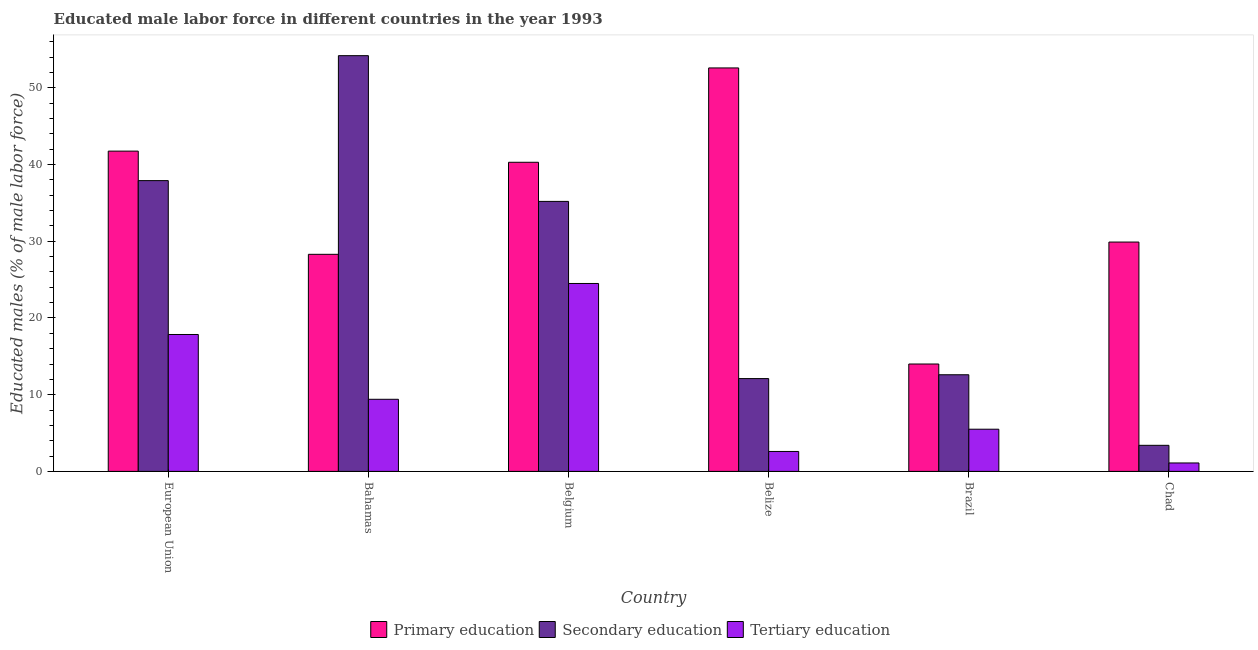Are the number of bars per tick equal to the number of legend labels?
Offer a very short reply. Yes. Are the number of bars on each tick of the X-axis equal?
Keep it short and to the point. Yes. What is the label of the 6th group of bars from the left?
Make the answer very short. Chad. In how many cases, is the number of bars for a given country not equal to the number of legend labels?
Offer a terse response. 0. What is the percentage of male labor force who received secondary education in Belgium?
Provide a succinct answer. 35.2. Across all countries, what is the maximum percentage of male labor force who received secondary education?
Make the answer very short. 54.2. In which country was the percentage of male labor force who received secondary education maximum?
Your answer should be very brief. Bahamas. In which country was the percentage of male labor force who received secondary education minimum?
Offer a very short reply. Chad. What is the total percentage of male labor force who received secondary education in the graph?
Make the answer very short. 155.41. What is the difference between the percentage of male labor force who received primary education in Chad and that in European Union?
Your answer should be compact. -11.86. What is the difference between the percentage of male labor force who received tertiary education in Bahamas and the percentage of male labor force who received primary education in European Union?
Your answer should be very brief. -32.36. What is the average percentage of male labor force who received primary education per country?
Give a very brief answer. 34.48. What is the difference between the percentage of male labor force who received primary education and percentage of male labor force who received tertiary education in European Union?
Offer a terse response. 23.91. In how many countries, is the percentage of male labor force who received tertiary education greater than 24 %?
Offer a terse response. 1. What is the ratio of the percentage of male labor force who received primary education in Belgium to that in European Union?
Offer a terse response. 0.97. Is the percentage of male labor force who received primary education in Bahamas less than that in Belgium?
Ensure brevity in your answer.  Yes. Is the difference between the percentage of male labor force who received tertiary education in Chad and European Union greater than the difference between the percentage of male labor force who received secondary education in Chad and European Union?
Make the answer very short. Yes. What is the difference between the highest and the second highest percentage of male labor force who received tertiary education?
Your answer should be compact. 6.65. What is the difference between the highest and the lowest percentage of male labor force who received secondary education?
Offer a terse response. 50.8. In how many countries, is the percentage of male labor force who received primary education greater than the average percentage of male labor force who received primary education taken over all countries?
Make the answer very short. 3. What does the 3rd bar from the right in European Union represents?
Give a very brief answer. Primary education. Is it the case that in every country, the sum of the percentage of male labor force who received primary education and percentage of male labor force who received secondary education is greater than the percentage of male labor force who received tertiary education?
Offer a very short reply. Yes. How many bars are there?
Ensure brevity in your answer.  18. Are the values on the major ticks of Y-axis written in scientific E-notation?
Ensure brevity in your answer.  No. How are the legend labels stacked?
Make the answer very short. Horizontal. What is the title of the graph?
Make the answer very short. Educated male labor force in different countries in the year 1993. Does "Maunufacturing" appear as one of the legend labels in the graph?
Keep it short and to the point. No. What is the label or title of the X-axis?
Offer a terse response. Country. What is the label or title of the Y-axis?
Offer a terse response. Educated males (% of male labor force). What is the Educated males (% of male labor force) in Primary education in European Union?
Your answer should be very brief. 41.76. What is the Educated males (% of male labor force) in Secondary education in European Union?
Make the answer very short. 37.91. What is the Educated males (% of male labor force) in Tertiary education in European Union?
Provide a succinct answer. 17.85. What is the Educated males (% of male labor force) of Primary education in Bahamas?
Your answer should be compact. 28.3. What is the Educated males (% of male labor force) of Secondary education in Bahamas?
Offer a very short reply. 54.2. What is the Educated males (% of male labor force) in Tertiary education in Bahamas?
Your answer should be very brief. 9.4. What is the Educated males (% of male labor force) of Primary education in Belgium?
Ensure brevity in your answer.  40.3. What is the Educated males (% of male labor force) of Secondary education in Belgium?
Ensure brevity in your answer.  35.2. What is the Educated males (% of male labor force) in Primary education in Belize?
Make the answer very short. 52.6. What is the Educated males (% of male labor force) in Secondary education in Belize?
Keep it short and to the point. 12.1. What is the Educated males (% of male labor force) of Tertiary education in Belize?
Provide a succinct answer. 2.6. What is the Educated males (% of male labor force) of Secondary education in Brazil?
Give a very brief answer. 12.6. What is the Educated males (% of male labor force) in Tertiary education in Brazil?
Provide a short and direct response. 5.5. What is the Educated males (% of male labor force) of Primary education in Chad?
Offer a terse response. 29.9. What is the Educated males (% of male labor force) in Secondary education in Chad?
Give a very brief answer. 3.4. What is the Educated males (% of male labor force) of Tertiary education in Chad?
Ensure brevity in your answer.  1.1. Across all countries, what is the maximum Educated males (% of male labor force) in Primary education?
Provide a succinct answer. 52.6. Across all countries, what is the maximum Educated males (% of male labor force) of Secondary education?
Make the answer very short. 54.2. Across all countries, what is the maximum Educated males (% of male labor force) of Tertiary education?
Your response must be concise. 24.5. Across all countries, what is the minimum Educated males (% of male labor force) of Primary education?
Your answer should be compact. 14. Across all countries, what is the minimum Educated males (% of male labor force) of Secondary education?
Provide a short and direct response. 3.4. Across all countries, what is the minimum Educated males (% of male labor force) of Tertiary education?
Keep it short and to the point. 1.1. What is the total Educated males (% of male labor force) in Primary education in the graph?
Provide a short and direct response. 206.86. What is the total Educated males (% of male labor force) in Secondary education in the graph?
Provide a succinct answer. 155.41. What is the total Educated males (% of male labor force) in Tertiary education in the graph?
Provide a short and direct response. 60.95. What is the difference between the Educated males (% of male labor force) in Primary education in European Union and that in Bahamas?
Your response must be concise. 13.46. What is the difference between the Educated males (% of male labor force) of Secondary education in European Union and that in Bahamas?
Your answer should be compact. -16.29. What is the difference between the Educated males (% of male labor force) of Tertiary education in European Union and that in Bahamas?
Your answer should be very brief. 8.45. What is the difference between the Educated males (% of male labor force) of Primary education in European Union and that in Belgium?
Offer a very short reply. 1.46. What is the difference between the Educated males (% of male labor force) in Secondary education in European Union and that in Belgium?
Provide a short and direct response. 2.71. What is the difference between the Educated males (% of male labor force) of Tertiary education in European Union and that in Belgium?
Give a very brief answer. -6.65. What is the difference between the Educated males (% of male labor force) in Primary education in European Union and that in Belize?
Your answer should be very brief. -10.84. What is the difference between the Educated males (% of male labor force) in Secondary education in European Union and that in Belize?
Make the answer very short. 25.81. What is the difference between the Educated males (% of male labor force) of Tertiary education in European Union and that in Belize?
Your answer should be compact. 15.25. What is the difference between the Educated males (% of male labor force) in Primary education in European Union and that in Brazil?
Your answer should be compact. 27.76. What is the difference between the Educated males (% of male labor force) of Secondary education in European Union and that in Brazil?
Your answer should be compact. 25.31. What is the difference between the Educated males (% of male labor force) in Tertiary education in European Union and that in Brazil?
Make the answer very short. 12.35. What is the difference between the Educated males (% of male labor force) of Primary education in European Union and that in Chad?
Offer a terse response. 11.86. What is the difference between the Educated males (% of male labor force) in Secondary education in European Union and that in Chad?
Make the answer very short. 34.51. What is the difference between the Educated males (% of male labor force) of Tertiary education in European Union and that in Chad?
Your answer should be very brief. 16.75. What is the difference between the Educated males (% of male labor force) of Tertiary education in Bahamas and that in Belgium?
Provide a succinct answer. -15.1. What is the difference between the Educated males (% of male labor force) in Primary education in Bahamas and that in Belize?
Your answer should be very brief. -24.3. What is the difference between the Educated males (% of male labor force) in Secondary education in Bahamas and that in Belize?
Make the answer very short. 42.1. What is the difference between the Educated males (% of male labor force) of Secondary education in Bahamas and that in Brazil?
Your answer should be very brief. 41.6. What is the difference between the Educated males (% of male labor force) of Primary education in Bahamas and that in Chad?
Give a very brief answer. -1.6. What is the difference between the Educated males (% of male labor force) of Secondary education in Bahamas and that in Chad?
Provide a short and direct response. 50.8. What is the difference between the Educated males (% of male labor force) in Secondary education in Belgium and that in Belize?
Ensure brevity in your answer.  23.1. What is the difference between the Educated males (% of male labor force) of Tertiary education in Belgium and that in Belize?
Your answer should be compact. 21.9. What is the difference between the Educated males (% of male labor force) of Primary education in Belgium and that in Brazil?
Your response must be concise. 26.3. What is the difference between the Educated males (% of male labor force) of Secondary education in Belgium and that in Brazil?
Offer a very short reply. 22.6. What is the difference between the Educated males (% of male labor force) in Primary education in Belgium and that in Chad?
Offer a terse response. 10.4. What is the difference between the Educated males (% of male labor force) of Secondary education in Belgium and that in Chad?
Provide a short and direct response. 31.8. What is the difference between the Educated males (% of male labor force) of Tertiary education in Belgium and that in Chad?
Provide a short and direct response. 23.4. What is the difference between the Educated males (% of male labor force) of Primary education in Belize and that in Brazil?
Give a very brief answer. 38.6. What is the difference between the Educated males (% of male labor force) in Primary education in Belize and that in Chad?
Ensure brevity in your answer.  22.7. What is the difference between the Educated males (% of male labor force) of Primary education in Brazil and that in Chad?
Provide a succinct answer. -15.9. What is the difference between the Educated males (% of male labor force) of Secondary education in Brazil and that in Chad?
Ensure brevity in your answer.  9.2. What is the difference between the Educated males (% of male labor force) of Tertiary education in Brazil and that in Chad?
Offer a very short reply. 4.4. What is the difference between the Educated males (% of male labor force) of Primary education in European Union and the Educated males (% of male labor force) of Secondary education in Bahamas?
Keep it short and to the point. -12.44. What is the difference between the Educated males (% of male labor force) in Primary education in European Union and the Educated males (% of male labor force) in Tertiary education in Bahamas?
Your answer should be compact. 32.36. What is the difference between the Educated males (% of male labor force) of Secondary education in European Union and the Educated males (% of male labor force) of Tertiary education in Bahamas?
Offer a very short reply. 28.51. What is the difference between the Educated males (% of male labor force) of Primary education in European Union and the Educated males (% of male labor force) of Secondary education in Belgium?
Your answer should be compact. 6.56. What is the difference between the Educated males (% of male labor force) in Primary education in European Union and the Educated males (% of male labor force) in Tertiary education in Belgium?
Your response must be concise. 17.26. What is the difference between the Educated males (% of male labor force) in Secondary education in European Union and the Educated males (% of male labor force) in Tertiary education in Belgium?
Provide a short and direct response. 13.41. What is the difference between the Educated males (% of male labor force) of Primary education in European Union and the Educated males (% of male labor force) of Secondary education in Belize?
Give a very brief answer. 29.66. What is the difference between the Educated males (% of male labor force) in Primary education in European Union and the Educated males (% of male labor force) in Tertiary education in Belize?
Make the answer very short. 39.16. What is the difference between the Educated males (% of male labor force) of Secondary education in European Union and the Educated males (% of male labor force) of Tertiary education in Belize?
Your answer should be very brief. 35.31. What is the difference between the Educated males (% of male labor force) of Primary education in European Union and the Educated males (% of male labor force) of Secondary education in Brazil?
Make the answer very short. 29.16. What is the difference between the Educated males (% of male labor force) of Primary education in European Union and the Educated males (% of male labor force) of Tertiary education in Brazil?
Your answer should be compact. 36.26. What is the difference between the Educated males (% of male labor force) of Secondary education in European Union and the Educated males (% of male labor force) of Tertiary education in Brazil?
Provide a short and direct response. 32.41. What is the difference between the Educated males (% of male labor force) in Primary education in European Union and the Educated males (% of male labor force) in Secondary education in Chad?
Provide a short and direct response. 38.36. What is the difference between the Educated males (% of male labor force) of Primary education in European Union and the Educated males (% of male labor force) of Tertiary education in Chad?
Ensure brevity in your answer.  40.66. What is the difference between the Educated males (% of male labor force) in Secondary education in European Union and the Educated males (% of male labor force) in Tertiary education in Chad?
Make the answer very short. 36.81. What is the difference between the Educated males (% of male labor force) of Primary education in Bahamas and the Educated males (% of male labor force) of Secondary education in Belgium?
Provide a short and direct response. -6.9. What is the difference between the Educated males (% of male labor force) of Secondary education in Bahamas and the Educated males (% of male labor force) of Tertiary education in Belgium?
Offer a terse response. 29.7. What is the difference between the Educated males (% of male labor force) of Primary education in Bahamas and the Educated males (% of male labor force) of Tertiary education in Belize?
Ensure brevity in your answer.  25.7. What is the difference between the Educated males (% of male labor force) in Secondary education in Bahamas and the Educated males (% of male labor force) in Tertiary education in Belize?
Provide a short and direct response. 51.6. What is the difference between the Educated males (% of male labor force) in Primary education in Bahamas and the Educated males (% of male labor force) in Secondary education in Brazil?
Keep it short and to the point. 15.7. What is the difference between the Educated males (% of male labor force) of Primary education in Bahamas and the Educated males (% of male labor force) of Tertiary education in Brazil?
Provide a short and direct response. 22.8. What is the difference between the Educated males (% of male labor force) of Secondary education in Bahamas and the Educated males (% of male labor force) of Tertiary education in Brazil?
Provide a succinct answer. 48.7. What is the difference between the Educated males (% of male labor force) in Primary education in Bahamas and the Educated males (% of male labor force) in Secondary education in Chad?
Make the answer very short. 24.9. What is the difference between the Educated males (% of male labor force) of Primary education in Bahamas and the Educated males (% of male labor force) of Tertiary education in Chad?
Provide a short and direct response. 27.2. What is the difference between the Educated males (% of male labor force) in Secondary education in Bahamas and the Educated males (% of male labor force) in Tertiary education in Chad?
Your answer should be compact. 53.1. What is the difference between the Educated males (% of male labor force) of Primary education in Belgium and the Educated males (% of male labor force) of Secondary education in Belize?
Your answer should be compact. 28.2. What is the difference between the Educated males (% of male labor force) of Primary education in Belgium and the Educated males (% of male labor force) of Tertiary education in Belize?
Offer a very short reply. 37.7. What is the difference between the Educated males (% of male labor force) of Secondary education in Belgium and the Educated males (% of male labor force) of Tertiary education in Belize?
Provide a short and direct response. 32.6. What is the difference between the Educated males (% of male labor force) of Primary education in Belgium and the Educated males (% of male labor force) of Secondary education in Brazil?
Provide a short and direct response. 27.7. What is the difference between the Educated males (% of male labor force) in Primary education in Belgium and the Educated males (% of male labor force) in Tertiary education in Brazil?
Offer a very short reply. 34.8. What is the difference between the Educated males (% of male labor force) in Secondary education in Belgium and the Educated males (% of male labor force) in Tertiary education in Brazil?
Your answer should be very brief. 29.7. What is the difference between the Educated males (% of male labor force) in Primary education in Belgium and the Educated males (% of male labor force) in Secondary education in Chad?
Make the answer very short. 36.9. What is the difference between the Educated males (% of male labor force) of Primary education in Belgium and the Educated males (% of male labor force) of Tertiary education in Chad?
Your answer should be compact. 39.2. What is the difference between the Educated males (% of male labor force) of Secondary education in Belgium and the Educated males (% of male labor force) of Tertiary education in Chad?
Keep it short and to the point. 34.1. What is the difference between the Educated males (% of male labor force) of Primary education in Belize and the Educated males (% of male labor force) of Secondary education in Brazil?
Provide a short and direct response. 40. What is the difference between the Educated males (% of male labor force) in Primary education in Belize and the Educated males (% of male labor force) in Tertiary education in Brazil?
Give a very brief answer. 47.1. What is the difference between the Educated males (% of male labor force) in Primary education in Belize and the Educated males (% of male labor force) in Secondary education in Chad?
Offer a very short reply. 49.2. What is the difference between the Educated males (% of male labor force) of Primary education in Belize and the Educated males (% of male labor force) of Tertiary education in Chad?
Your answer should be compact. 51.5. What is the difference between the Educated males (% of male labor force) in Primary education in Brazil and the Educated males (% of male labor force) in Secondary education in Chad?
Your response must be concise. 10.6. What is the difference between the Educated males (% of male labor force) of Primary education in Brazil and the Educated males (% of male labor force) of Tertiary education in Chad?
Your response must be concise. 12.9. What is the difference between the Educated males (% of male labor force) of Secondary education in Brazil and the Educated males (% of male labor force) of Tertiary education in Chad?
Your answer should be compact. 11.5. What is the average Educated males (% of male labor force) in Primary education per country?
Offer a terse response. 34.48. What is the average Educated males (% of male labor force) of Secondary education per country?
Provide a succinct answer. 25.9. What is the average Educated males (% of male labor force) of Tertiary education per country?
Make the answer very short. 10.16. What is the difference between the Educated males (% of male labor force) in Primary education and Educated males (% of male labor force) in Secondary education in European Union?
Make the answer very short. 3.85. What is the difference between the Educated males (% of male labor force) in Primary education and Educated males (% of male labor force) in Tertiary education in European Union?
Your answer should be very brief. 23.91. What is the difference between the Educated males (% of male labor force) in Secondary education and Educated males (% of male labor force) in Tertiary education in European Union?
Your response must be concise. 20.06. What is the difference between the Educated males (% of male labor force) in Primary education and Educated males (% of male labor force) in Secondary education in Bahamas?
Keep it short and to the point. -25.9. What is the difference between the Educated males (% of male labor force) of Primary education and Educated males (% of male labor force) of Tertiary education in Bahamas?
Ensure brevity in your answer.  18.9. What is the difference between the Educated males (% of male labor force) in Secondary education and Educated males (% of male labor force) in Tertiary education in Bahamas?
Offer a terse response. 44.8. What is the difference between the Educated males (% of male labor force) of Secondary education and Educated males (% of male labor force) of Tertiary education in Belgium?
Offer a very short reply. 10.7. What is the difference between the Educated males (% of male labor force) in Primary education and Educated males (% of male labor force) in Secondary education in Belize?
Offer a very short reply. 40.5. What is the difference between the Educated males (% of male labor force) in Secondary education and Educated males (% of male labor force) in Tertiary education in Belize?
Keep it short and to the point. 9.5. What is the difference between the Educated males (% of male labor force) of Primary education and Educated males (% of male labor force) of Secondary education in Brazil?
Your response must be concise. 1.4. What is the difference between the Educated males (% of male labor force) of Primary education and Educated males (% of male labor force) of Tertiary education in Brazil?
Your answer should be very brief. 8.5. What is the difference between the Educated males (% of male labor force) in Primary education and Educated males (% of male labor force) in Tertiary education in Chad?
Offer a terse response. 28.8. What is the difference between the Educated males (% of male labor force) of Secondary education and Educated males (% of male labor force) of Tertiary education in Chad?
Your answer should be very brief. 2.3. What is the ratio of the Educated males (% of male labor force) of Primary education in European Union to that in Bahamas?
Ensure brevity in your answer.  1.48. What is the ratio of the Educated males (% of male labor force) of Secondary education in European Union to that in Bahamas?
Provide a succinct answer. 0.7. What is the ratio of the Educated males (% of male labor force) of Tertiary education in European Union to that in Bahamas?
Your answer should be compact. 1.9. What is the ratio of the Educated males (% of male labor force) in Primary education in European Union to that in Belgium?
Your response must be concise. 1.04. What is the ratio of the Educated males (% of male labor force) in Secondary education in European Union to that in Belgium?
Provide a short and direct response. 1.08. What is the ratio of the Educated males (% of male labor force) in Tertiary education in European Union to that in Belgium?
Offer a very short reply. 0.73. What is the ratio of the Educated males (% of male labor force) in Primary education in European Union to that in Belize?
Provide a short and direct response. 0.79. What is the ratio of the Educated males (% of male labor force) in Secondary education in European Union to that in Belize?
Your answer should be compact. 3.13. What is the ratio of the Educated males (% of male labor force) in Tertiary education in European Union to that in Belize?
Make the answer very short. 6.86. What is the ratio of the Educated males (% of male labor force) of Primary education in European Union to that in Brazil?
Offer a terse response. 2.98. What is the ratio of the Educated males (% of male labor force) in Secondary education in European Union to that in Brazil?
Offer a terse response. 3.01. What is the ratio of the Educated males (% of male labor force) in Tertiary education in European Union to that in Brazil?
Offer a terse response. 3.25. What is the ratio of the Educated males (% of male labor force) in Primary education in European Union to that in Chad?
Ensure brevity in your answer.  1.4. What is the ratio of the Educated males (% of male labor force) in Secondary education in European Union to that in Chad?
Provide a succinct answer. 11.15. What is the ratio of the Educated males (% of male labor force) of Tertiary education in European Union to that in Chad?
Give a very brief answer. 16.23. What is the ratio of the Educated males (% of male labor force) in Primary education in Bahamas to that in Belgium?
Give a very brief answer. 0.7. What is the ratio of the Educated males (% of male labor force) in Secondary education in Bahamas to that in Belgium?
Offer a very short reply. 1.54. What is the ratio of the Educated males (% of male labor force) in Tertiary education in Bahamas to that in Belgium?
Keep it short and to the point. 0.38. What is the ratio of the Educated males (% of male labor force) of Primary education in Bahamas to that in Belize?
Provide a short and direct response. 0.54. What is the ratio of the Educated males (% of male labor force) in Secondary education in Bahamas to that in Belize?
Keep it short and to the point. 4.48. What is the ratio of the Educated males (% of male labor force) of Tertiary education in Bahamas to that in Belize?
Offer a very short reply. 3.62. What is the ratio of the Educated males (% of male labor force) in Primary education in Bahamas to that in Brazil?
Offer a very short reply. 2.02. What is the ratio of the Educated males (% of male labor force) in Secondary education in Bahamas to that in Brazil?
Make the answer very short. 4.3. What is the ratio of the Educated males (% of male labor force) in Tertiary education in Bahamas to that in Brazil?
Your answer should be very brief. 1.71. What is the ratio of the Educated males (% of male labor force) in Primary education in Bahamas to that in Chad?
Ensure brevity in your answer.  0.95. What is the ratio of the Educated males (% of male labor force) in Secondary education in Bahamas to that in Chad?
Offer a terse response. 15.94. What is the ratio of the Educated males (% of male labor force) in Tertiary education in Bahamas to that in Chad?
Offer a terse response. 8.55. What is the ratio of the Educated males (% of male labor force) of Primary education in Belgium to that in Belize?
Provide a short and direct response. 0.77. What is the ratio of the Educated males (% of male labor force) of Secondary education in Belgium to that in Belize?
Keep it short and to the point. 2.91. What is the ratio of the Educated males (% of male labor force) of Tertiary education in Belgium to that in Belize?
Your answer should be compact. 9.42. What is the ratio of the Educated males (% of male labor force) in Primary education in Belgium to that in Brazil?
Your answer should be very brief. 2.88. What is the ratio of the Educated males (% of male labor force) of Secondary education in Belgium to that in Brazil?
Offer a very short reply. 2.79. What is the ratio of the Educated males (% of male labor force) in Tertiary education in Belgium to that in Brazil?
Make the answer very short. 4.45. What is the ratio of the Educated males (% of male labor force) of Primary education in Belgium to that in Chad?
Your response must be concise. 1.35. What is the ratio of the Educated males (% of male labor force) in Secondary education in Belgium to that in Chad?
Provide a short and direct response. 10.35. What is the ratio of the Educated males (% of male labor force) in Tertiary education in Belgium to that in Chad?
Ensure brevity in your answer.  22.27. What is the ratio of the Educated males (% of male labor force) in Primary education in Belize to that in Brazil?
Provide a succinct answer. 3.76. What is the ratio of the Educated males (% of male labor force) of Secondary education in Belize to that in Brazil?
Give a very brief answer. 0.96. What is the ratio of the Educated males (% of male labor force) in Tertiary education in Belize to that in Brazil?
Provide a short and direct response. 0.47. What is the ratio of the Educated males (% of male labor force) of Primary education in Belize to that in Chad?
Give a very brief answer. 1.76. What is the ratio of the Educated males (% of male labor force) in Secondary education in Belize to that in Chad?
Offer a terse response. 3.56. What is the ratio of the Educated males (% of male labor force) in Tertiary education in Belize to that in Chad?
Provide a succinct answer. 2.36. What is the ratio of the Educated males (% of male labor force) of Primary education in Brazil to that in Chad?
Your answer should be very brief. 0.47. What is the ratio of the Educated males (% of male labor force) of Secondary education in Brazil to that in Chad?
Your response must be concise. 3.71. What is the ratio of the Educated males (% of male labor force) of Tertiary education in Brazil to that in Chad?
Ensure brevity in your answer.  5. What is the difference between the highest and the second highest Educated males (% of male labor force) of Primary education?
Your response must be concise. 10.84. What is the difference between the highest and the second highest Educated males (% of male labor force) of Secondary education?
Ensure brevity in your answer.  16.29. What is the difference between the highest and the second highest Educated males (% of male labor force) of Tertiary education?
Give a very brief answer. 6.65. What is the difference between the highest and the lowest Educated males (% of male labor force) in Primary education?
Ensure brevity in your answer.  38.6. What is the difference between the highest and the lowest Educated males (% of male labor force) of Secondary education?
Your answer should be compact. 50.8. What is the difference between the highest and the lowest Educated males (% of male labor force) in Tertiary education?
Keep it short and to the point. 23.4. 